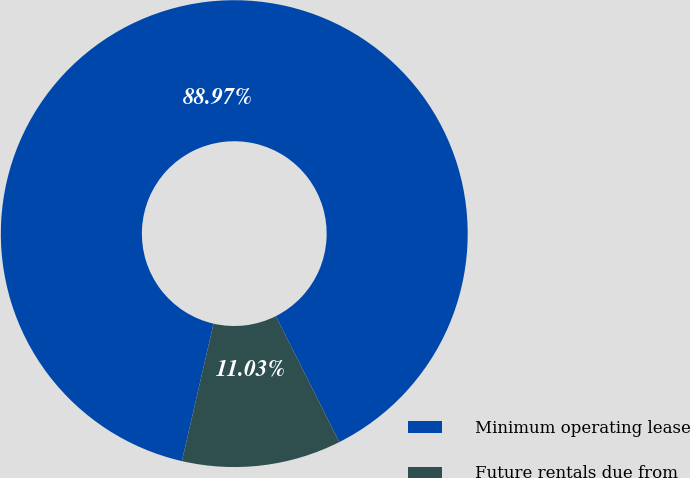Convert chart. <chart><loc_0><loc_0><loc_500><loc_500><pie_chart><fcel>Minimum operating lease<fcel>Future rentals due from<nl><fcel>88.97%<fcel>11.03%<nl></chart> 